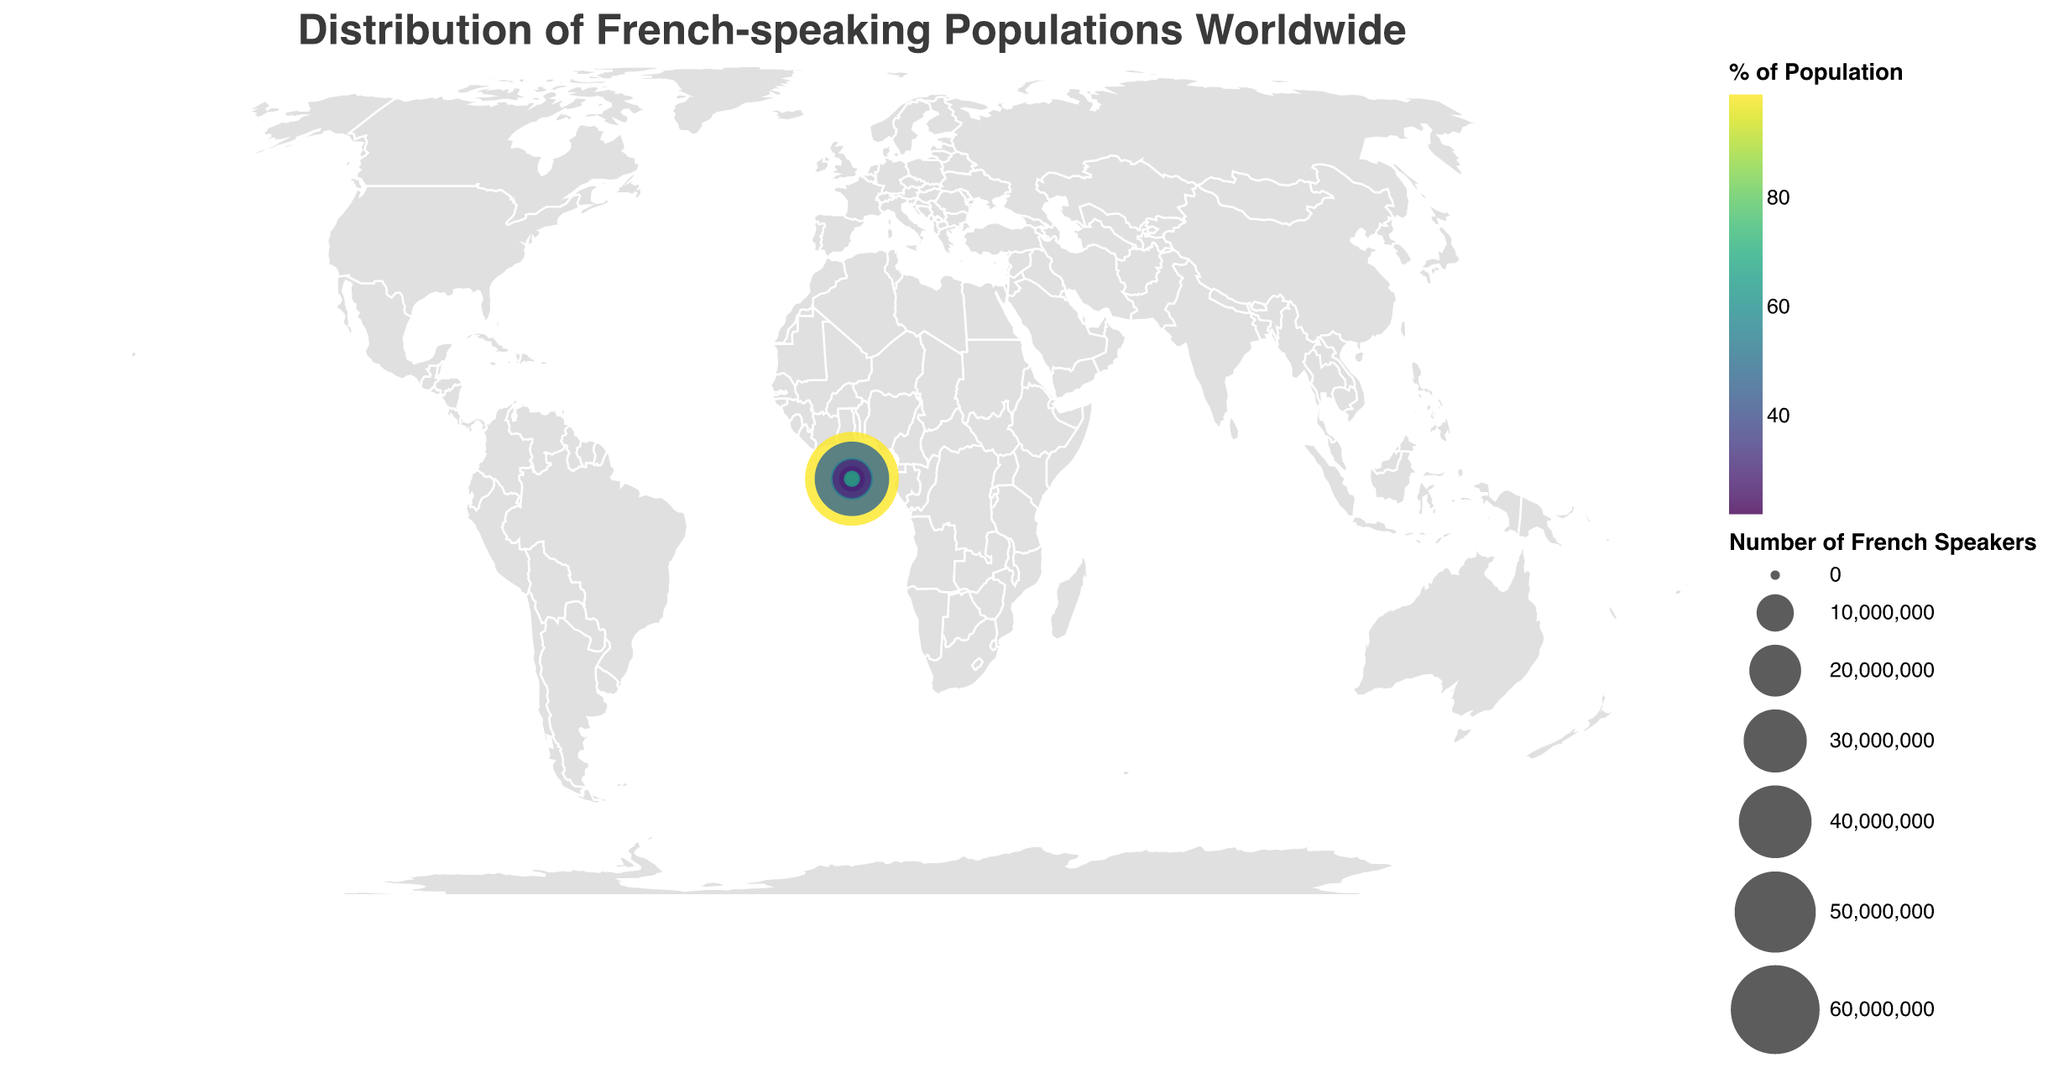What is the title of the figure? The title of the figure is shown at the top of the chart. It provides an overall description of what the chart represents. In this case, it gives information about the distribution of French-speaking populations worldwide.
Answer: Distribution of French-speaking Populations Worldwide Which country has the highest number of French speakers? To find the country with the highest number of French speakers, look for the largest circle on the map. The size of the circle represents the number of French speakers.
Answer: France What is the color scheme used for representing the percentage of the population that speaks French? The map uses different colors to represent the percentage of the population that speaks French, and this is indicated by the legend. The colors change from one end to the other in a gradation. The scale used is Viridis.
Answer: Viridis Which country has the highest percentage of French speakers relative to its total population? Look for the country with the darkest color on the map since darker colors represent higher percentages of French speakers. According to the legend, the darkest color corresponds to the highest percentage.
Answer: France What country has a French-speaking population of over 40 million? To identify the country with over 40 million French speakers, check the tooltip information for the approximate population counts. The size of the circle can also guide you in finding large populations.
Answer: Democratic Republic of the Congo Among the listed African countries, which one has the highest percentage of French-speaking population? Identify the African countries on the map and compare their colors based on the legend. The country with the darkest color has the highest percentage of French speakers.
Answer: Gabon How many countries have a French-speaking population that is more than 40% of their total population? Count the countries where the circle's color indicates 40% or more based on the legend for percentages. Sum up the number of such countries.
Answer: 5 countries What are the combined French-speaking populations of Belgium, Switzerland, and Luxembourg? Add the French-speaking populations of Belgium, Switzerland, and Luxembourg. The values are given as 4500000 + 2000000 + 400000.
Answer: 6900000 Compare the French-speaking populations of Ivory Coast and Morocco. Which one is higher? Check the tooltip or data associated with Ivory Coast and Morocco. Compare the figures provided for their French-speaking populations.
Answer: Ivory Coast Which country in the Americas apart from Canada has a significant French-speaking population and what is its percentage? Identify countries in the Americas shown on the map and check their tooltip informations. Focus on countries other than Canada.
Answer: Haiti, 95% 